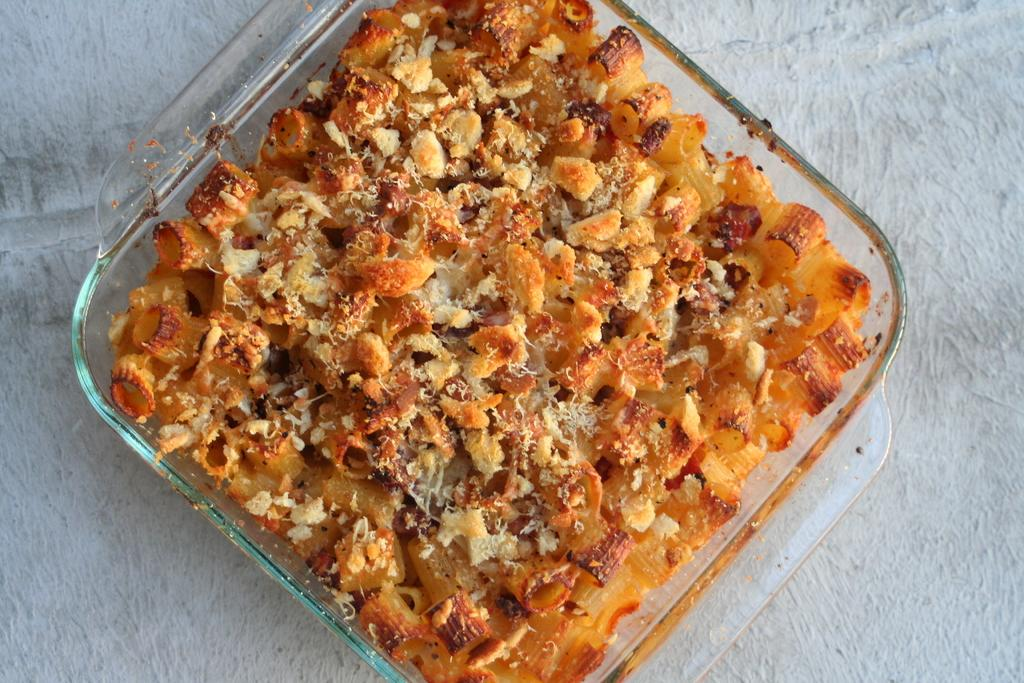What type of container is holding the food in the image? There is food in a tiffin box in the image. What color is the background of the image? The background of the image is white. How many gloves can be seen in the image? There are no gloves present in the image. What type of bird is perched on the tiffin box in the image? There is no bird, specifically a wren, present in the image. 